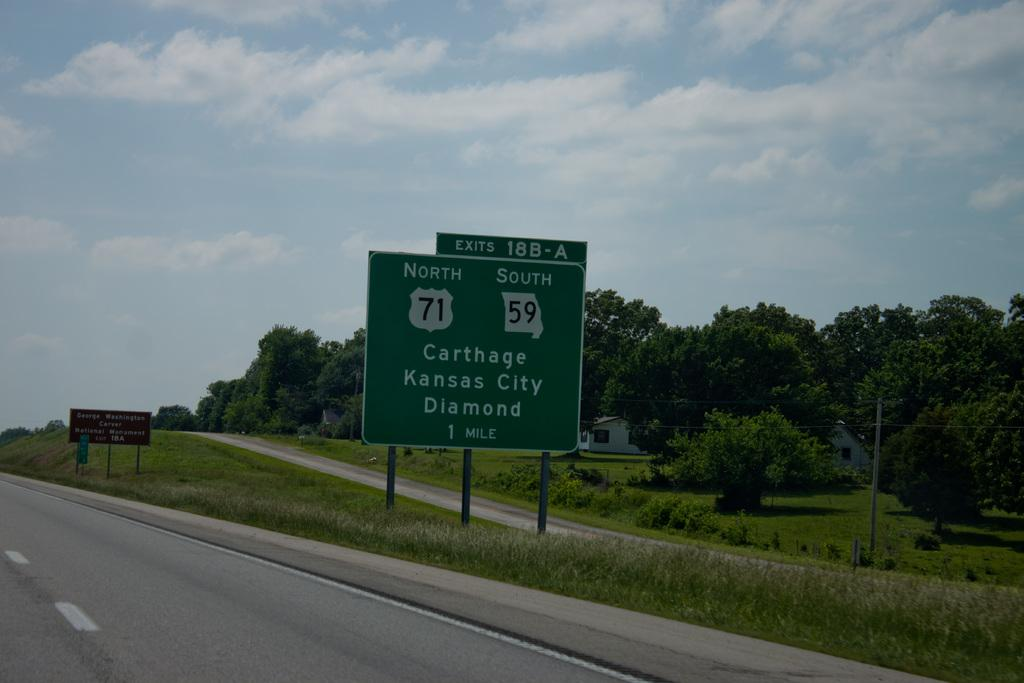<image>
Render a clear and concise summary of the photo. A highway sign informs travelers that Carthage, Kansas City and Diamond are one mile away. 